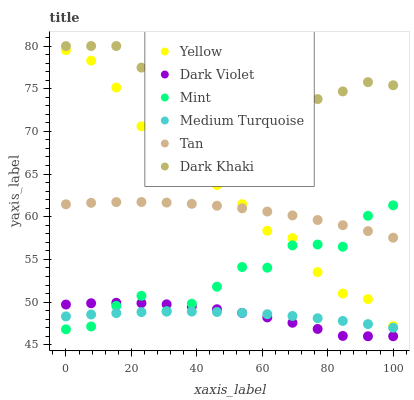Does Dark Violet have the minimum area under the curve?
Answer yes or no. Yes. Does Dark Khaki have the maximum area under the curve?
Answer yes or no. Yes. Does Yellow have the minimum area under the curve?
Answer yes or no. No. Does Yellow have the maximum area under the curve?
Answer yes or no. No. Is Medium Turquoise the smoothest?
Answer yes or no. Yes. Is Mint the roughest?
Answer yes or no. Yes. Is Dark Khaki the smoothest?
Answer yes or no. No. Is Dark Khaki the roughest?
Answer yes or no. No. Does Dark Violet have the lowest value?
Answer yes or no. Yes. Does Yellow have the lowest value?
Answer yes or no. No. Does Dark Khaki have the highest value?
Answer yes or no. Yes. Does Yellow have the highest value?
Answer yes or no. No. Is Yellow less than Dark Khaki?
Answer yes or no. Yes. Is Dark Khaki greater than Tan?
Answer yes or no. Yes. Does Medium Turquoise intersect Mint?
Answer yes or no. Yes. Is Medium Turquoise less than Mint?
Answer yes or no. No. Is Medium Turquoise greater than Mint?
Answer yes or no. No. Does Yellow intersect Dark Khaki?
Answer yes or no. No. 